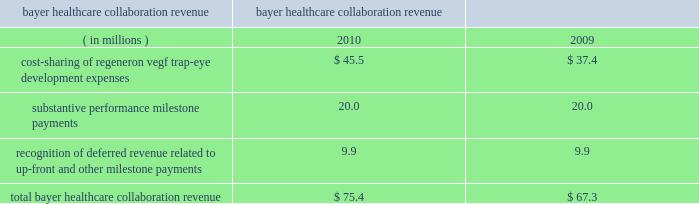Recognition of deferred revenue related to sanofi-aventis 2019 $ 85.0 million up-front payment decreased in 2010 compared to 2009 due to the november 2009 amendments to expand and extend the companies 2019 antibody collaboration .
In connection with the november 2009 amendment of the discovery agreement , sanofi-aventis is funding up to $ 30 million of agreed-upon costs incurred by us to expand our manufacturing capacity at our rensselaer , new york facilities , of which $ 23.4 million was received or receivable from sanofi-aventis as of december 31 , 2010 .
Revenue related to these payments for such funding from sanofi-aventis is deferred and recognized as collaboration revenue prospectively over the related performance period in conjunction with the recognition of the original $ 85.0 million up-front payment .
As of december 31 , 2010 , $ 79.8 million of the sanofi-aventis payments was deferred and will be recognized as revenue in future periods .
In august 2008 , we entered into a separate velocigene ae agreement with sanofi-aventis .
In 2010 and 2009 , we recognized $ 1.6 million and $ 2.7 million , respectively , in revenue related to this agreement .
Bayer healthcare collaboration revenue the collaboration revenue we earned from bayer healthcare , as detailed below , consisted of cost sharing of regeneron vegf trap-eye development expenses , substantive performance milestone payments , and recognition of revenue related to a non-refundable $ 75.0 million up-front payment received in october 2006 and a $ 20.0 million milestone payment received in august 2007 ( which , for the purpose of revenue recognition , was not considered substantive ) .
Years ended bayer healthcare collaboration revenue december 31 .
Cost-sharing of our vegf trap-eye development expenses with bayer healthcare increased in 2010 compared to 2009 due to higher internal development activities and higher clinical development costs in connection with our phase 3 copernicus trial in crvo .
In the fourth quarter of 2010 , we earned two $ 10.0 million substantive milestone payments from bayer healthcare for achieving positive 52-week results in the view 1 study and positive 6-month results in the copernicus study .
In july 2009 , we earned a $ 20.0 million substantive performance milestone payment from bayer healthcare in connection with the dosing of the first patient in the copernicus study .
In connection with the recognition of deferred revenue related to the $ 75.0 million up-front payment and $ 20.0 million milestone payment received in august 2007 , as of december 31 , 2010 , $ 47.0 million of these payments was deferred and will be recognized as revenue in future periods .
Technology licensing revenue in connection with our velocimmune ae license agreements with astrazeneca and astellas , each of the $ 20.0 million annual , non-refundable payments were deferred upon receipt and recognized as revenue ratably over approximately the ensuing year of each agreement .
In both 2010 and 2009 , we recognized $ 40.0 million of technology licensing revenue related to these agreements .
In addition , in connection with the amendment and extension of our license agreement with astellas , in august 2010 , we received a $ 165.0 million up-front payment , which was deferred upon receipt and will be recognized as revenue ratably over a seven-year period beginning in mid-2011 .
As of december 31 , 2010 , $ 176.6 million of these technology licensing payments was deferred and will be recognized as revenue in future periods .
Net product sales in 2010 and 2009 , we recognized as revenue $ 25.3 million and $ 18.4 million , respectively , of arcalyst ae net product sales for which both the right of return no longer existed and rebates could be reasonably estimated .
The company had limited historical return experience for arcalyst ae beginning with initial sales in 2008 through the end of 2009 ; therefore , arcalyst ae net product sales were deferred until the right of return no longer existed and rebates could be reasonably estimated .
Effective in the first quarter of 2010 , the company determined that it had .
What was the change in millions of total bayer healthcare collaboration revenue from 2009 to 2010? 
Computations: (75.4 - 67.3)
Answer: 8.1. 